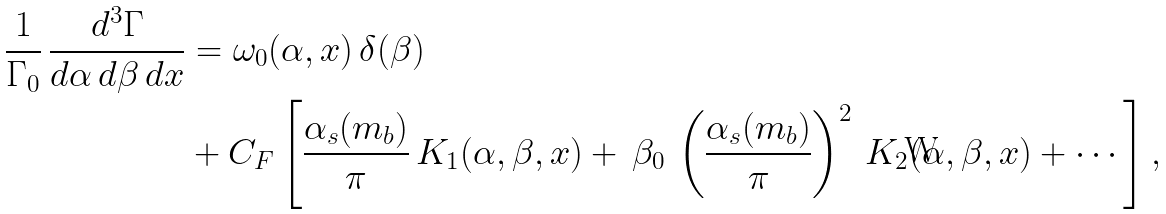<formula> <loc_0><loc_0><loc_500><loc_500>\frac { 1 } { \Gamma _ { 0 } } \, \frac { d ^ { 3 } \Gamma } { d \alpha \, d \beta \, d x } & = \omega _ { 0 } ( \alpha , x ) \, \delta ( \beta ) \\ & + C _ { F } \left [ \frac { \alpha _ { s } ( m _ { b } ) } { \pi } \, K _ { 1 } ( \alpha , \beta , x ) + \, \beta _ { 0 } \, \left ( \frac { \alpha _ { s } ( m _ { b } ) } { \pi } \right ) ^ { 2 } \, K _ { 2 } ( \alpha , \beta , x ) + \cdots \right ] ,</formula> 